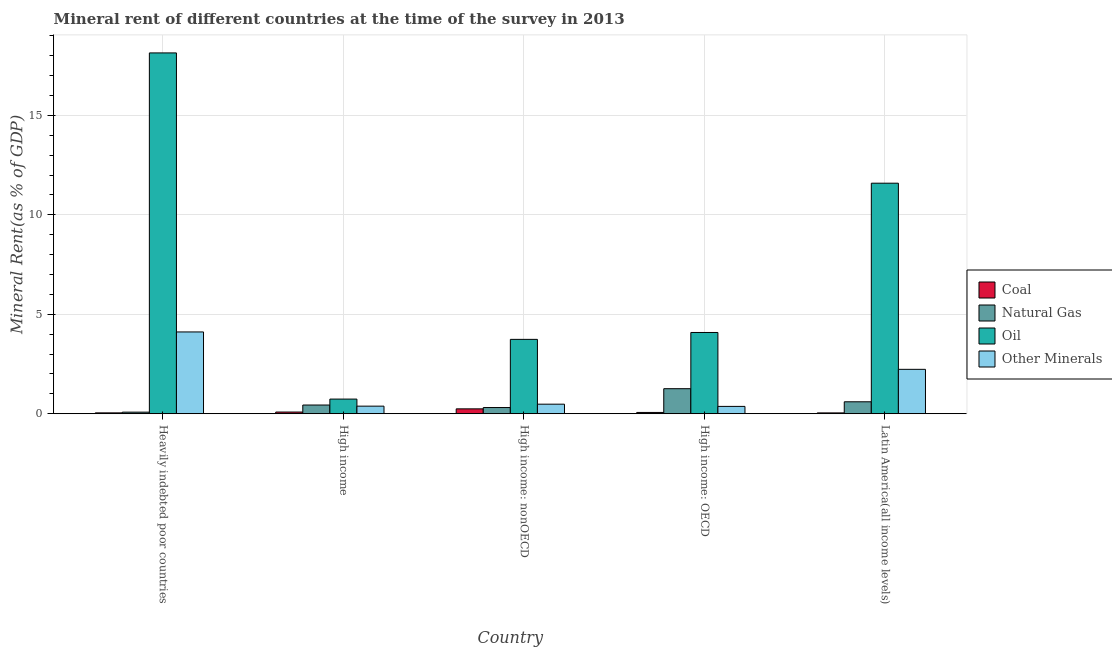How many groups of bars are there?
Provide a succinct answer. 5. Are the number of bars on each tick of the X-axis equal?
Your answer should be very brief. Yes. How many bars are there on the 3rd tick from the right?
Provide a succinct answer. 4. What is the label of the 4th group of bars from the left?
Make the answer very short. High income: OECD. What is the coal rent in High income: nonOECD?
Provide a succinct answer. 0.25. Across all countries, what is the maximum  rent of other minerals?
Your response must be concise. 4.11. Across all countries, what is the minimum  rent of other minerals?
Your answer should be compact. 0.37. In which country was the natural gas rent maximum?
Make the answer very short. High income: OECD. What is the total natural gas rent in the graph?
Ensure brevity in your answer.  2.69. What is the difference between the oil rent in Heavily indebted poor countries and that in Latin America(all income levels)?
Give a very brief answer. 6.55. What is the difference between the natural gas rent in Heavily indebted poor countries and the coal rent in High income?
Keep it short and to the point. -0.01. What is the average natural gas rent per country?
Ensure brevity in your answer.  0.54. What is the difference between the coal rent and natural gas rent in Heavily indebted poor countries?
Your answer should be compact. -0.04. What is the ratio of the oil rent in High income: nonOECD to that in Latin America(all income levels)?
Your response must be concise. 0.32. Is the  rent of other minerals in High income: nonOECD less than that in Latin America(all income levels)?
Ensure brevity in your answer.  Yes. What is the difference between the highest and the second highest  rent of other minerals?
Give a very brief answer. 1.88. What is the difference between the highest and the lowest  rent of other minerals?
Provide a succinct answer. 3.74. What does the 1st bar from the left in High income: nonOECD represents?
Offer a very short reply. Coal. What does the 1st bar from the right in High income: nonOECD represents?
Make the answer very short. Other Minerals. Does the graph contain grids?
Offer a terse response. Yes. Where does the legend appear in the graph?
Provide a succinct answer. Center right. How many legend labels are there?
Your answer should be very brief. 4. How are the legend labels stacked?
Your answer should be compact. Vertical. What is the title of the graph?
Ensure brevity in your answer.  Mineral rent of different countries at the time of the survey in 2013. Does "Revenue mobilization" appear as one of the legend labels in the graph?
Give a very brief answer. No. What is the label or title of the X-axis?
Offer a very short reply. Country. What is the label or title of the Y-axis?
Offer a very short reply. Mineral Rent(as % of GDP). What is the Mineral Rent(as % of GDP) in Coal in Heavily indebted poor countries?
Your answer should be compact. 0.04. What is the Mineral Rent(as % of GDP) in Natural Gas in Heavily indebted poor countries?
Keep it short and to the point. 0.08. What is the Mineral Rent(as % of GDP) in Oil in Heavily indebted poor countries?
Provide a succinct answer. 18.15. What is the Mineral Rent(as % of GDP) in Other Minerals in Heavily indebted poor countries?
Give a very brief answer. 4.11. What is the Mineral Rent(as % of GDP) of Coal in High income?
Offer a terse response. 0.09. What is the Mineral Rent(as % of GDP) of Natural Gas in High income?
Ensure brevity in your answer.  0.44. What is the Mineral Rent(as % of GDP) of Oil in High income?
Your answer should be very brief. 0.74. What is the Mineral Rent(as % of GDP) of Other Minerals in High income?
Provide a succinct answer. 0.38. What is the Mineral Rent(as % of GDP) of Coal in High income: nonOECD?
Your answer should be compact. 0.25. What is the Mineral Rent(as % of GDP) of Natural Gas in High income: nonOECD?
Offer a very short reply. 0.31. What is the Mineral Rent(as % of GDP) in Oil in High income: nonOECD?
Offer a very short reply. 3.74. What is the Mineral Rent(as % of GDP) in Other Minerals in High income: nonOECD?
Your answer should be compact. 0.48. What is the Mineral Rent(as % of GDP) of Coal in High income: OECD?
Your response must be concise. 0.07. What is the Mineral Rent(as % of GDP) in Natural Gas in High income: OECD?
Your response must be concise. 1.26. What is the Mineral Rent(as % of GDP) of Oil in High income: OECD?
Offer a terse response. 4.09. What is the Mineral Rent(as % of GDP) in Other Minerals in High income: OECD?
Offer a very short reply. 0.37. What is the Mineral Rent(as % of GDP) in Coal in Latin America(all income levels)?
Ensure brevity in your answer.  0.04. What is the Mineral Rent(as % of GDP) in Natural Gas in Latin America(all income levels)?
Ensure brevity in your answer.  0.6. What is the Mineral Rent(as % of GDP) of Oil in Latin America(all income levels)?
Your answer should be very brief. 11.59. What is the Mineral Rent(as % of GDP) of Other Minerals in Latin America(all income levels)?
Offer a very short reply. 2.23. Across all countries, what is the maximum Mineral Rent(as % of GDP) of Coal?
Make the answer very short. 0.25. Across all countries, what is the maximum Mineral Rent(as % of GDP) in Natural Gas?
Provide a short and direct response. 1.26. Across all countries, what is the maximum Mineral Rent(as % of GDP) of Oil?
Ensure brevity in your answer.  18.15. Across all countries, what is the maximum Mineral Rent(as % of GDP) in Other Minerals?
Offer a terse response. 4.11. Across all countries, what is the minimum Mineral Rent(as % of GDP) in Coal?
Give a very brief answer. 0.04. Across all countries, what is the minimum Mineral Rent(as % of GDP) of Natural Gas?
Provide a short and direct response. 0.08. Across all countries, what is the minimum Mineral Rent(as % of GDP) in Oil?
Keep it short and to the point. 0.74. Across all countries, what is the minimum Mineral Rent(as % of GDP) in Other Minerals?
Make the answer very short. 0.37. What is the total Mineral Rent(as % of GDP) of Coal in the graph?
Keep it short and to the point. 0.48. What is the total Mineral Rent(as % of GDP) of Natural Gas in the graph?
Offer a terse response. 2.69. What is the total Mineral Rent(as % of GDP) of Oil in the graph?
Ensure brevity in your answer.  38.3. What is the total Mineral Rent(as % of GDP) in Other Minerals in the graph?
Offer a terse response. 7.58. What is the difference between the Mineral Rent(as % of GDP) in Coal in Heavily indebted poor countries and that in High income?
Provide a succinct answer. -0.04. What is the difference between the Mineral Rent(as % of GDP) in Natural Gas in Heavily indebted poor countries and that in High income?
Your answer should be compact. -0.36. What is the difference between the Mineral Rent(as % of GDP) in Oil in Heavily indebted poor countries and that in High income?
Provide a short and direct response. 17.41. What is the difference between the Mineral Rent(as % of GDP) of Other Minerals in Heavily indebted poor countries and that in High income?
Your answer should be compact. 3.73. What is the difference between the Mineral Rent(as % of GDP) in Coal in Heavily indebted poor countries and that in High income: nonOECD?
Make the answer very short. -0.2. What is the difference between the Mineral Rent(as % of GDP) in Natural Gas in Heavily indebted poor countries and that in High income: nonOECD?
Your answer should be compact. -0.23. What is the difference between the Mineral Rent(as % of GDP) in Oil in Heavily indebted poor countries and that in High income: nonOECD?
Provide a succinct answer. 14.41. What is the difference between the Mineral Rent(as % of GDP) of Other Minerals in Heavily indebted poor countries and that in High income: nonOECD?
Give a very brief answer. 3.63. What is the difference between the Mineral Rent(as % of GDP) of Coal in Heavily indebted poor countries and that in High income: OECD?
Offer a terse response. -0.02. What is the difference between the Mineral Rent(as % of GDP) in Natural Gas in Heavily indebted poor countries and that in High income: OECD?
Your answer should be compact. -1.18. What is the difference between the Mineral Rent(as % of GDP) of Oil in Heavily indebted poor countries and that in High income: OECD?
Offer a terse response. 14.06. What is the difference between the Mineral Rent(as % of GDP) in Other Minerals in Heavily indebted poor countries and that in High income: OECD?
Your answer should be very brief. 3.74. What is the difference between the Mineral Rent(as % of GDP) in Coal in Heavily indebted poor countries and that in Latin America(all income levels)?
Provide a short and direct response. 0. What is the difference between the Mineral Rent(as % of GDP) in Natural Gas in Heavily indebted poor countries and that in Latin America(all income levels)?
Your answer should be very brief. -0.52. What is the difference between the Mineral Rent(as % of GDP) of Oil in Heavily indebted poor countries and that in Latin America(all income levels)?
Keep it short and to the point. 6.55. What is the difference between the Mineral Rent(as % of GDP) of Other Minerals in Heavily indebted poor countries and that in Latin America(all income levels)?
Keep it short and to the point. 1.88. What is the difference between the Mineral Rent(as % of GDP) in Coal in High income and that in High income: nonOECD?
Offer a very short reply. -0.16. What is the difference between the Mineral Rent(as % of GDP) of Natural Gas in High income and that in High income: nonOECD?
Make the answer very short. 0.13. What is the difference between the Mineral Rent(as % of GDP) of Oil in High income and that in High income: nonOECD?
Ensure brevity in your answer.  -3. What is the difference between the Mineral Rent(as % of GDP) in Other Minerals in High income and that in High income: nonOECD?
Your answer should be very brief. -0.1. What is the difference between the Mineral Rent(as % of GDP) of Coal in High income and that in High income: OECD?
Provide a short and direct response. 0.02. What is the difference between the Mineral Rent(as % of GDP) in Natural Gas in High income and that in High income: OECD?
Give a very brief answer. -0.82. What is the difference between the Mineral Rent(as % of GDP) in Oil in High income and that in High income: OECD?
Ensure brevity in your answer.  -3.35. What is the difference between the Mineral Rent(as % of GDP) in Other Minerals in High income and that in High income: OECD?
Offer a terse response. 0.01. What is the difference between the Mineral Rent(as % of GDP) of Coal in High income and that in Latin America(all income levels)?
Ensure brevity in your answer.  0.04. What is the difference between the Mineral Rent(as % of GDP) in Natural Gas in High income and that in Latin America(all income levels)?
Give a very brief answer. -0.16. What is the difference between the Mineral Rent(as % of GDP) in Oil in High income and that in Latin America(all income levels)?
Make the answer very short. -10.86. What is the difference between the Mineral Rent(as % of GDP) in Other Minerals in High income and that in Latin America(all income levels)?
Your answer should be compact. -1.85. What is the difference between the Mineral Rent(as % of GDP) of Coal in High income: nonOECD and that in High income: OECD?
Offer a very short reply. 0.18. What is the difference between the Mineral Rent(as % of GDP) in Natural Gas in High income: nonOECD and that in High income: OECD?
Your response must be concise. -0.95. What is the difference between the Mineral Rent(as % of GDP) in Oil in High income: nonOECD and that in High income: OECD?
Your answer should be compact. -0.35. What is the difference between the Mineral Rent(as % of GDP) in Other Minerals in High income: nonOECD and that in High income: OECD?
Your response must be concise. 0.11. What is the difference between the Mineral Rent(as % of GDP) of Coal in High income: nonOECD and that in Latin America(all income levels)?
Keep it short and to the point. 0.2. What is the difference between the Mineral Rent(as % of GDP) of Natural Gas in High income: nonOECD and that in Latin America(all income levels)?
Provide a succinct answer. -0.29. What is the difference between the Mineral Rent(as % of GDP) in Oil in High income: nonOECD and that in Latin America(all income levels)?
Keep it short and to the point. -7.85. What is the difference between the Mineral Rent(as % of GDP) in Other Minerals in High income: nonOECD and that in Latin America(all income levels)?
Offer a very short reply. -1.75. What is the difference between the Mineral Rent(as % of GDP) of Coal in High income: OECD and that in Latin America(all income levels)?
Ensure brevity in your answer.  0.02. What is the difference between the Mineral Rent(as % of GDP) of Natural Gas in High income: OECD and that in Latin America(all income levels)?
Your response must be concise. 0.66. What is the difference between the Mineral Rent(as % of GDP) in Oil in High income: OECD and that in Latin America(all income levels)?
Your answer should be compact. -7.51. What is the difference between the Mineral Rent(as % of GDP) of Other Minerals in High income: OECD and that in Latin America(all income levels)?
Offer a very short reply. -1.86. What is the difference between the Mineral Rent(as % of GDP) in Coal in Heavily indebted poor countries and the Mineral Rent(as % of GDP) in Natural Gas in High income?
Ensure brevity in your answer.  -0.39. What is the difference between the Mineral Rent(as % of GDP) in Coal in Heavily indebted poor countries and the Mineral Rent(as % of GDP) in Oil in High income?
Make the answer very short. -0.69. What is the difference between the Mineral Rent(as % of GDP) in Coal in Heavily indebted poor countries and the Mineral Rent(as % of GDP) in Other Minerals in High income?
Your answer should be very brief. -0.34. What is the difference between the Mineral Rent(as % of GDP) of Natural Gas in Heavily indebted poor countries and the Mineral Rent(as % of GDP) of Oil in High income?
Provide a succinct answer. -0.66. What is the difference between the Mineral Rent(as % of GDP) of Natural Gas in Heavily indebted poor countries and the Mineral Rent(as % of GDP) of Other Minerals in High income?
Offer a very short reply. -0.3. What is the difference between the Mineral Rent(as % of GDP) of Oil in Heavily indebted poor countries and the Mineral Rent(as % of GDP) of Other Minerals in High income?
Your answer should be compact. 17.76. What is the difference between the Mineral Rent(as % of GDP) of Coal in Heavily indebted poor countries and the Mineral Rent(as % of GDP) of Natural Gas in High income: nonOECD?
Your answer should be very brief. -0.27. What is the difference between the Mineral Rent(as % of GDP) in Coal in Heavily indebted poor countries and the Mineral Rent(as % of GDP) in Oil in High income: nonOECD?
Offer a very short reply. -3.7. What is the difference between the Mineral Rent(as % of GDP) of Coal in Heavily indebted poor countries and the Mineral Rent(as % of GDP) of Other Minerals in High income: nonOECD?
Your response must be concise. -0.44. What is the difference between the Mineral Rent(as % of GDP) in Natural Gas in Heavily indebted poor countries and the Mineral Rent(as % of GDP) in Oil in High income: nonOECD?
Provide a succinct answer. -3.66. What is the difference between the Mineral Rent(as % of GDP) in Natural Gas in Heavily indebted poor countries and the Mineral Rent(as % of GDP) in Other Minerals in High income: nonOECD?
Your answer should be compact. -0.4. What is the difference between the Mineral Rent(as % of GDP) of Oil in Heavily indebted poor countries and the Mineral Rent(as % of GDP) of Other Minerals in High income: nonOECD?
Give a very brief answer. 17.66. What is the difference between the Mineral Rent(as % of GDP) of Coal in Heavily indebted poor countries and the Mineral Rent(as % of GDP) of Natural Gas in High income: OECD?
Offer a very short reply. -1.22. What is the difference between the Mineral Rent(as % of GDP) in Coal in Heavily indebted poor countries and the Mineral Rent(as % of GDP) in Oil in High income: OECD?
Provide a succinct answer. -4.04. What is the difference between the Mineral Rent(as % of GDP) in Coal in Heavily indebted poor countries and the Mineral Rent(as % of GDP) in Other Minerals in High income: OECD?
Provide a short and direct response. -0.33. What is the difference between the Mineral Rent(as % of GDP) of Natural Gas in Heavily indebted poor countries and the Mineral Rent(as % of GDP) of Oil in High income: OECD?
Ensure brevity in your answer.  -4.01. What is the difference between the Mineral Rent(as % of GDP) of Natural Gas in Heavily indebted poor countries and the Mineral Rent(as % of GDP) of Other Minerals in High income: OECD?
Keep it short and to the point. -0.29. What is the difference between the Mineral Rent(as % of GDP) of Oil in Heavily indebted poor countries and the Mineral Rent(as % of GDP) of Other Minerals in High income: OECD?
Your response must be concise. 17.78. What is the difference between the Mineral Rent(as % of GDP) in Coal in Heavily indebted poor countries and the Mineral Rent(as % of GDP) in Natural Gas in Latin America(all income levels)?
Give a very brief answer. -0.56. What is the difference between the Mineral Rent(as % of GDP) of Coal in Heavily indebted poor countries and the Mineral Rent(as % of GDP) of Oil in Latin America(all income levels)?
Your answer should be very brief. -11.55. What is the difference between the Mineral Rent(as % of GDP) of Coal in Heavily indebted poor countries and the Mineral Rent(as % of GDP) of Other Minerals in Latin America(all income levels)?
Offer a very short reply. -2.19. What is the difference between the Mineral Rent(as % of GDP) in Natural Gas in Heavily indebted poor countries and the Mineral Rent(as % of GDP) in Oil in Latin America(all income levels)?
Your answer should be compact. -11.51. What is the difference between the Mineral Rent(as % of GDP) of Natural Gas in Heavily indebted poor countries and the Mineral Rent(as % of GDP) of Other Minerals in Latin America(all income levels)?
Offer a very short reply. -2.15. What is the difference between the Mineral Rent(as % of GDP) in Oil in Heavily indebted poor countries and the Mineral Rent(as % of GDP) in Other Minerals in Latin America(all income levels)?
Give a very brief answer. 15.91. What is the difference between the Mineral Rent(as % of GDP) of Coal in High income and the Mineral Rent(as % of GDP) of Natural Gas in High income: nonOECD?
Your answer should be very brief. -0.23. What is the difference between the Mineral Rent(as % of GDP) in Coal in High income and the Mineral Rent(as % of GDP) in Oil in High income: nonOECD?
Ensure brevity in your answer.  -3.65. What is the difference between the Mineral Rent(as % of GDP) of Coal in High income and the Mineral Rent(as % of GDP) of Other Minerals in High income: nonOECD?
Offer a very short reply. -0.4. What is the difference between the Mineral Rent(as % of GDP) in Natural Gas in High income and the Mineral Rent(as % of GDP) in Oil in High income: nonOECD?
Your answer should be compact. -3.3. What is the difference between the Mineral Rent(as % of GDP) of Natural Gas in High income and the Mineral Rent(as % of GDP) of Other Minerals in High income: nonOECD?
Keep it short and to the point. -0.04. What is the difference between the Mineral Rent(as % of GDP) in Oil in High income and the Mineral Rent(as % of GDP) in Other Minerals in High income: nonOECD?
Offer a very short reply. 0.26. What is the difference between the Mineral Rent(as % of GDP) of Coal in High income and the Mineral Rent(as % of GDP) of Natural Gas in High income: OECD?
Provide a succinct answer. -1.17. What is the difference between the Mineral Rent(as % of GDP) of Coal in High income and the Mineral Rent(as % of GDP) of Oil in High income: OECD?
Keep it short and to the point. -4. What is the difference between the Mineral Rent(as % of GDP) in Coal in High income and the Mineral Rent(as % of GDP) in Other Minerals in High income: OECD?
Ensure brevity in your answer.  -0.28. What is the difference between the Mineral Rent(as % of GDP) in Natural Gas in High income and the Mineral Rent(as % of GDP) in Oil in High income: OECD?
Make the answer very short. -3.65. What is the difference between the Mineral Rent(as % of GDP) in Natural Gas in High income and the Mineral Rent(as % of GDP) in Other Minerals in High income: OECD?
Your answer should be compact. 0.07. What is the difference between the Mineral Rent(as % of GDP) in Oil in High income and the Mineral Rent(as % of GDP) in Other Minerals in High income: OECD?
Your response must be concise. 0.37. What is the difference between the Mineral Rent(as % of GDP) in Coal in High income and the Mineral Rent(as % of GDP) in Natural Gas in Latin America(all income levels)?
Keep it short and to the point. -0.52. What is the difference between the Mineral Rent(as % of GDP) of Coal in High income and the Mineral Rent(as % of GDP) of Oil in Latin America(all income levels)?
Your answer should be compact. -11.51. What is the difference between the Mineral Rent(as % of GDP) of Coal in High income and the Mineral Rent(as % of GDP) of Other Minerals in Latin America(all income levels)?
Give a very brief answer. -2.15. What is the difference between the Mineral Rent(as % of GDP) of Natural Gas in High income and the Mineral Rent(as % of GDP) of Oil in Latin America(all income levels)?
Your response must be concise. -11.15. What is the difference between the Mineral Rent(as % of GDP) of Natural Gas in High income and the Mineral Rent(as % of GDP) of Other Minerals in Latin America(all income levels)?
Ensure brevity in your answer.  -1.79. What is the difference between the Mineral Rent(as % of GDP) of Oil in High income and the Mineral Rent(as % of GDP) of Other Minerals in Latin America(all income levels)?
Your answer should be very brief. -1.5. What is the difference between the Mineral Rent(as % of GDP) of Coal in High income: nonOECD and the Mineral Rent(as % of GDP) of Natural Gas in High income: OECD?
Your answer should be very brief. -1.01. What is the difference between the Mineral Rent(as % of GDP) of Coal in High income: nonOECD and the Mineral Rent(as % of GDP) of Oil in High income: OECD?
Your answer should be compact. -3.84. What is the difference between the Mineral Rent(as % of GDP) in Coal in High income: nonOECD and the Mineral Rent(as % of GDP) in Other Minerals in High income: OECD?
Offer a terse response. -0.12. What is the difference between the Mineral Rent(as % of GDP) of Natural Gas in High income: nonOECD and the Mineral Rent(as % of GDP) of Oil in High income: OECD?
Provide a short and direct response. -3.77. What is the difference between the Mineral Rent(as % of GDP) of Natural Gas in High income: nonOECD and the Mineral Rent(as % of GDP) of Other Minerals in High income: OECD?
Your answer should be compact. -0.06. What is the difference between the Mineral Rent(as % of GDP) of Oil in High income: nonOECD and the Mineral Rent(as % of GDP) of Other Minerals in High income: OECD?
Your answer should be compact. 3.37. What is the difference between the Mineral Rent(as % of GDP) of Coal in High income: nonOECD and the Mineral Rent(as % of GDP) of Natural Gas in Latin America(all income levels)?
Provide a short and direct response. -0.36. What is the difference between the Mineral Rent(as % of GDP) in Coal in High income: nonOECD and the Mineral Rent(as % of GDP) in Oil in Latin America(all income levels)?
Offer a terse response. -11.35. What is the difference between the Mineral Rent(as % of GDP) in Coal in High income: nonOECD and the Mineral Rent(as % of GDP) in Other Minerals in Latin America(all income levels)?
Provide a succinct answer. -1.99. What is the difference between the Mineral Rent(as % of GDP) of Natural Gas in High income: nonOECD and the Mineral Rent(as % of GDP) of Oil in Latin America(all income levels)?
Provide a succinct answer. -11.28. What is the difference between the Mineral Rent(as % of GDP) of Natural Gas in High income: nonOECD and the Mineral Rent(as % of GDP) of Other Minerals in Latin America(all income levels)?
Provide a succinct answer. -1.92. What is the difference between the Mineral Rent(as % of GDP) in Oil in High income: nonOECD and the Mineral Rent(as % of GDP) in Other Minerals in Latin America(all income levels)?
Give a very brief answer. 1.51. What is the difference between the Mineral Rent(as % of GDP) in Coal in High income: OECD and the Mineral Rent(as % of GDP) in Natural Gas in Latin America(all income levels)?
Provide a short and direct response. -0.54. What is the difference between the Mineral Rent(as % of GDP) of Coal in High income: OECD and the Mineral Rent(as % of GDP) of Oil in Latin America(all income levels)?
Give a very brief answer. -11.53. What is the difference between the Mineral Rent(as % of GDP) in Coal in High income: OECD and the Mineral Rent(as % of GDP) in Other Minerals in Latin America(all income levels)?
Offer a very short reply. -2.17. What is the difference between the Mineral Rent(as % of GDP) of Natural Gas in High income: OECD and the Mineral Rent(as % of GDP) of Oil in Latin America(all income levels)?
Your answer should be compact. -10.33. What is the difference between the Mineral Rent(as % of GDP) of Natural Gas in High income: OECD and the Mineral Rent(as % of GDP) of Other Minerals in Latin America(all income levels)?
Provide a short and direct response. -0.97. What is the difference between the Mineral Rent(as % of GDP) of Oil in High income: OECD and the Mineral Rent(as % of GDP) of Other Minerals in Latin America(all income levels)?
Provide a succinct answer. 1.85. What is the average Mineral Rent(as % of GDP) in Coal per country?
Ensure brevity in your answer.  0.1. What is the average Mineral Rent(as % of GDP) in Natural Gas per country?
Ensure brevity in your answer.  0.54. What is the average Mineral Rent(as % of GDP) of Oil per country?
Your answer should be very brief. 7.66. What is the average Mineral Rent(as % of GDP) of Other Minerals per country?
Keep it short and to the point. 1.52. What is the difference between the Mineral Rent(as % of GDP) of Coal and Mineral Rent(as % of GDP) of Natural Gas in Heavily indebted poor countries?
Offer a terse response. -0.04. What is the difference between the Mineral Rent(as % of GDP) in Coal and Mineral Rent(as % of GDP) in Oil in Heavily indebted poor countries?
Your answer should be very brief. -18.1. What is the difference between the Mineral Rent(as % of GDP) of Coal and Mineral Rent(as % of GDP) of Other Minerals in Heavily indebted poor countries?
Give a very brief answer. -4.07. What is the difference between the Mineral Rent(as % of GDP) in Natural Gas and Mineral Rent(as % of GDP) in Oil in Heavily indebted poor countries?
Your response must be concise. -18.07. What is the difference between the Mineral Rent(as % of GDP) in Natural Gas and Mineral Rent(as % of GDP) in Other Minerals in Heavily indebted poor countries?
Ensure brevity in your answer.  -4.03. What is the difference between the Mineral Rent(as % of GDP) of Oil and Mineral Rent(as % of GDP) of Other Minerals in Heavily indebted poor countries?
Your answer should be compact. 14.03. What is the difference between the Mineral Rent(as % of GDP) of Coal and Mineral Rent(as % of GDP) of Natural Gas in High income?
Make the answer very short. -0.35. What is the difference between the Mineral Rent(as % of GDP) in Coal and Mineral Rent(as % of GDP) in Oil in High income?
Your answer should be very brief. -0.65. What is the difference between the Mineral Rent(as % of GDP) of Coal and Mineral Rent(as % of GDP) of Other Minerals in High income?
Offer a terse response. -0.3. What is the difference between the Mineral Rent(as % of GDP) in Natural Gas and Mineral Rent(as % of GDP) in Oil in High income?
Your response must be concise. -0.3. What is the difference between the Mineral Rent(as % of GDP) in Natural Gas and Mineral Rent(as % of GDP) in Other Minerals in High income?
Your response must be concise. 0.06. What is the difference between the Mineral Rent(as % of GDP) of Oil and Mineral Rent(as % of GDP) of Other Minerals in High income?
Provide a short and direct response. 0.35. What is the difference between the Mineral Rent(as % of GDP) of Coal and Mineral Rent(as % of GDP) of Natural Gas in High income: nonOECD?
Give a very brief answer. -0.07. What is the difference between the Mineral Rent(as % of GDP) in Coal and Mineral Rent(as % of GDP) in Oil in High income: nonOECD?
Your response must be concise. -3.49. What is the difference between the Mineral Rent(as % of GDP) of Coal and Mineral Rent(as % of GDP) of Other Minerals in High income: nonOECD?
Ensure brevity in your answer.  -0.24. What is the difference between the Mineral Rent(as % of GDP) in Natural Gas and Mineral Rent(as % of GDP) in Oil in High income: nonOECD?
Give a very brief answer. -3.43. What is the difference between the Mineral Rent(as % of GDP) of Natural Gas and Mineral Rent(as % of GDP) of Other Minerals in High income: nonOECD?
Ensure brevity in your answer.  -0.17. What is the difference between the Mineral Rent(as % of GDP) of Oil and Mineral Rent(as % of GDP) of Other Minerals in High income: nonOECD?
Give a very brief answer. 3.26. What is the difference between the Mineral Rent(as % of GDP) in Coal and Mineral Rent(as % of GDP) in Natural Gas in High income: OECD?
Provide a succinct answer. -1.19. What is the difference between the Mineral Rent(as % of GDP) of Coal and Mineral Rent(as % of GDP) of Oil in High income: OECD?
Your answer should be compact. -4.02. What is the difference between the Mineral Rent(as % of GDP) in Coal and Mineral Rent(as % of GDP) in Other Minerals in High income: OECD?
Ensure brevity in your answer.  -0.3. What is the difference between the Mineral Rent(as % of GDP) in Natural Gas and Mineral Rent(as % of GDP) in Oil in High income: OECD?
Offer a terse response. -2.83. What is the difference between the Mineral Rent(as % of GDP) of Natural Gas and Mineral Rent(as % of GDP) of Other Minerals in High income: OECD?
Offer a terse response. 0.89. What is the difference between the Mineral Rent(as % of GDP) of Oil and Mineral Rent(as % of GDP) of Other Minerals in High income: OECD?
Give a very brief answer. 3.72. What is the difference between the Mineral Rent(as % of GDP) in Coal and Mineral Rent(as % of GDP) in Natural Gas in Latin America(all income levels)?
Give a very brief answer. -0.56. What is the difference between the Mineral Rent(as % of GDP) in Coal and Mineral Rent(as % of GDP) in Oil in Latin America(all income levels)?
Make the answer very short. -11.55. What is the difference between the Mineral Rent(as % of GDP) of Coal and Mineral Rent(as % of GDP) of Other Minerals in Latin America(all income levels)?
Your answer should be compact. -2.19. What is the difference between the Mineral Rent(as % of GDP) in Natural Gas and Mineral Rent(as % of GDP) in Oil in Latin America(all income levels)?
Offer a very short reply. -10.99. What is the difference between the Mineral Rent(as % of GDP) of Natural Gas and Mineral Rent(as % of GDP) of Other Minerals in Latin America(all income levels)?
Provide a short and direct response. -1.63. What is the difference between the Mineral Rent(as % of GDP) of Oil and Mineral Rent(as % of GDP) of Other Minerals in Latin America(all income levels)?
Give a very brief answer. 9.36. What is the ratio of the Mineral Rent(as % of GDP) of Coal in Heavily indebted poor countries to that in High income?
Give a very brief answer. 0.51. What is the ratio of the Mineral Rent(as % of GDP) in Natural Gas in Heavily indebted poor countries to that in High income?
Give a very brief answer. 0.18. What is the ratio of the Mineral Rent(as % of GDP) in Oil in Heavily indebted poor countries to that in High income?
Give a very brief answer. 24.63. What is the ratio of the Mineral Rent(as % of GDP) of Other Minerals in Heavily indebted poor countries to that in High income?
Keep it short and to the point. 10.77. What is the ratio of the Mineral Rent(as % of GDP) in Coal in Heavily indebted poor countries to that in High income: nonOECD?
Your response must be concise. 0.18. What is the ratio of the Mineral Rent(as % of GDP) of Natural Gas in Heavily indebted poor countries to that in High income: nonOECD?
Your answer should be very brief. 0.26. What is the ratio of the Mineral Rent(as % of GDP) of Oil in Heavily indebted poor countries to that in High income: nonOECD?
Ensure brevity in your answer.  4.85. What is the ratio of the Mineral Rent(as % of GDP) in Other Minerals in Heavily indebted poor countries to that in High income: nonOECD?
Provide a succinct answer. 8.55. What is the ratio of the Mineral Rent(as % of GDP) of Coal in Heavily indebted poor countries to that in High income: OECD?
Provide a short and direct response. 0.67. What is the ratio of the Mineral Rent(as % of GDP) of Natural Gas in Heavily indebted poor countries to that in High income: OECD?
Offer a terse response. 0.06. What is the ratio of the Mineral Rent(as % of GDP) in Oil in Heavily indebted poor countries to that in High income: OECD?
Your response must be concise. 4.44. What is the ratio of the Mineral Rent(as % of GDP) of Other Minerals in Heavily indebted poor countries to that in High income: OECD?
Offer a very short reply. 11.15. What is the ratio of the Mineral Rent(as % of GDP) of Coal in Heavily indebted poor countries to that in Latin America(all income levels)?
Ensure brevity in your answer.  1.03. What is the ratio of the Mineral Rent(as % of GDP) of Natural Gas in Heavily indebted poor countries to that in Latin America(all income levels)?
Make the answer very short. 0.13. What is the ratio of the Mineral Rent(as % of GDP) of Oil in Heavily indebted poor countries to that in Latin America(all income levels)?
Provide a succinct answer. 1.57. What is the ratio of the Mineral Rent(as % of GDP) of Other Minerals in Heavily indebted poor countries to that in Latin America(all income levels)?
Offer a very short reply. 1.84. What is the ratio of the Mineral Rent(as % of GDP) in Coal in High income to that in High income: nonOECD?
Give a very brief answer. 0.35. What is the ratio of the Mineral Rent(as % of GDP) of Natural Gas in High income to that in High income: nonOECD?
Provide a succinct answer. 1.41. What is the ratio of the Mineral Rent(as % of GDP) of Oil in High income to that in High income: nonOECD?
Offer a very short reply. 0.2. What is the ratio of the Mineral Rent(as % of GDP) in Other Minerals in High income to that in High income: nonOECD?
Offer a very short reply. 0.79. What is the ratio of the Mineral Rent(as % of GDP) in Coal in High income to that in High income: OECD?
Offer a terse response. 1.32. What is the ratio of the Mineral Rent(as % of GDP) in Natural Gas in High income to that in High income: OECD?
Provide a short and direct response. 0.35. What is the ratio of the Mineral Rent(as % of GDP) in Oil in High income to that in High income: OECD?
Ensure brevity in your answer.  0.18. What is the ratio of the Mineral Rent(as % of GDP) of Other Minerals in High income to that in High income: OECD?
Your answer should be very brief. 1.03. What is the ratio of the Mineral Rent(as % of GDP) of Coal in High income to that in Latin America(all income levels)?
Make the answer very short. 2.01. What is the ratio of the Mineral Rent(as % of GDP) of Natural Gas in High income to that in Latin America(all income levels)?
Offer a terse response. 0.73. What is the ratio of the Mineral Rent(as % of GDP) of Oil in High income to that in Latin America(all income levels)?
Provide a short and direct response. 0.06. What is the ratio of the Mineral Rent(as % of GDP) in Other Minerals in High income to that in Latin America(all income levels)?
Offer a terse response. 0.17. What is the ratio of the Mineral Rent(as % of GDP) in Coal in High income: nonOECD to that in High income: OECD?
Give a very brief answer. 3.77. What is the ratio of the Mineral Rent(as % of GDP) of Natural Gas in High income: nonOECD to that in High income: OECD?
Make the answer very short. 0.25. What is the ratio of the Mineral Rent(as % of GDP) in Oil in High income: nonOECD to that in High income: OECD?
Ensure brevity in your answer.  0.92. What is the ratio of the Mineral Rent(as % of GDP) of Other Minerals in High income: nonOECD to that in High income: OECD?
Offer a very short reply. 1.3. What is the ratio of the Mineral Rent(as % of GDP) of Coal in High income: nonOECD to that in Latin America(all income levels)?
Provide a short and direct response. 5.78. What is the ratio of the Mineral Rent(as % of GDP) in Natural Gas in High income: nonOECD to that in Latin America(all income levels)?
Offer a very short reply. 0.52. What is the ratio of the Mineral Rent(as % of GDP) of Oil in High income: nonOECD to that in Latin America(all income levels)?
Offer a terse response. 0.32. What is the ratio of the Mineral Rent(as % of GDP) in Other Minerals in High income: nonOECD to that in Latin America(all income levels)?
Your answer should be compact. 0.22. What is the ratio of the Mineral Rent(as % of GDP) of Coal in High income: OECD to that in Latin America(all income levels)?
Provide a short and direct response. 1.53. What is the ratio of the Mineral Rent(as % of GDP) in Natural Gas in High income: OECD to that in Latin America(all income levels)?
Make the answer very short. 2.1. What is the ratio of the Mineral Rent(as % of GDP) of Oil in High income: OECD to that in Latin America(all income levels)?
Keep it short and to the point. 0.35. What is the ratio of the Mineral Rent(as % of GDP) in Other Minerals in High income: OECD to that in Latin America(all income levels)?
Offer a terse response. 0.17. What is the difference between the highest and the second highest Mineral Rent(as % of GDP) of Coal?
Your response must be concise. 0.16. What is the difference between the highest and the second highest Mineral Rent(as % of GDP) of Natural Gas?
Make the answer very short. 0.66. What is the difference between the highest and the second highest Mineral Rent(as % of GDP) of Oil?
Your response must be concise. 6.55. What is the difference between the highest and the second highest Mineral Rent(as % of GDP) in Other Minerals?
Provide a short and direct response. 1.88. What is the difference between the highest and the lowest Mineral Rent(as % of GDP) of Coal?
Your response must be concise. 0.2. What is the difference between the highest and the lowest Mineral Rent(as % of GDP) in Natural Gas?
Your answer should be very brief. 1.18. What is the difference between the highest and the lowest Mineral Rent(as % of GDP) in Oil?
Offer a terse response. 17.41. What is the difference between the highest and the lowest Mineral Rent(as % of GDP) of Other Minerals?
Offer a very short reply. 3.74. 